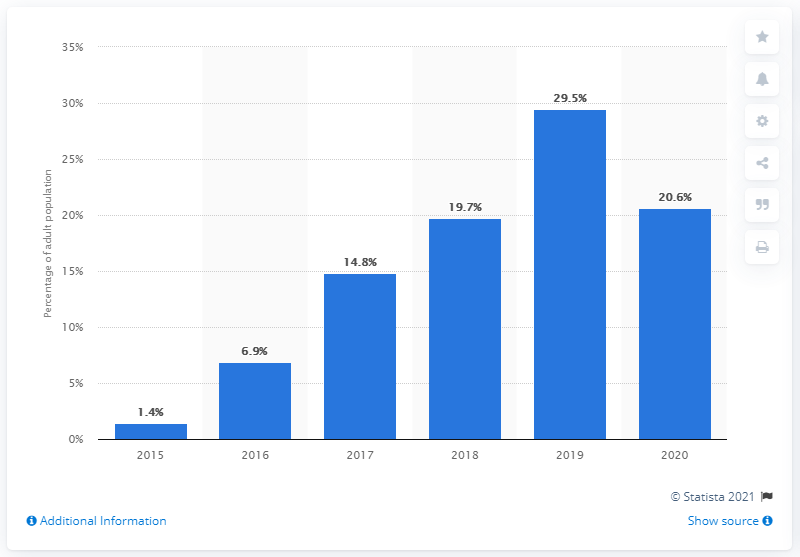Identify some key points in this picture. In 2020, it was reported that 20.6% of adults in Vietnam had credit bureau coverage. 